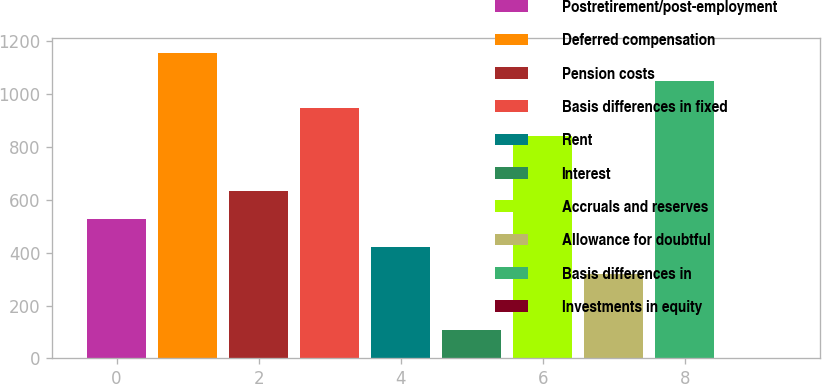Convert chart to OTSL. <chart><loc_0><loc_0><loc_500><loc_500><bar_chart><fcel>Postretirement/post-employment<fcel>Deferred compensation<fcel>Pension costs<fcel>Basis differences in fixed<fcel>Rent<fcel>Interest<fcel>Accruals and reserves<fcel>Allowance for doubtful<fcel>Basis differences in<fcel>Investments in equity<nl><fcel>527.3<fcel>1156.22<fcel>632.12<fcel>946.58<fcel>422.48<fcel>108.02<fcel>841.76<fcel>317.66<fcel>1051.4<fcel>3.2<nl></chart> 